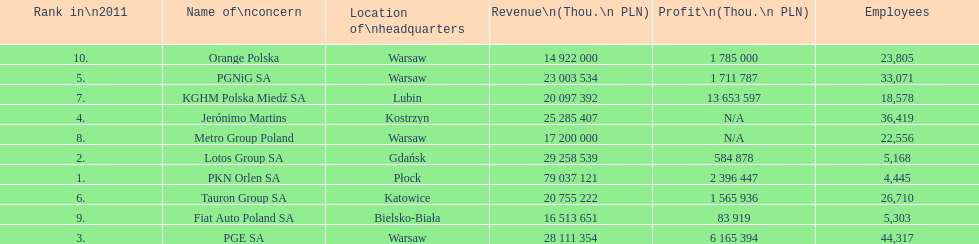Which company had the most employees? PGE SA. 